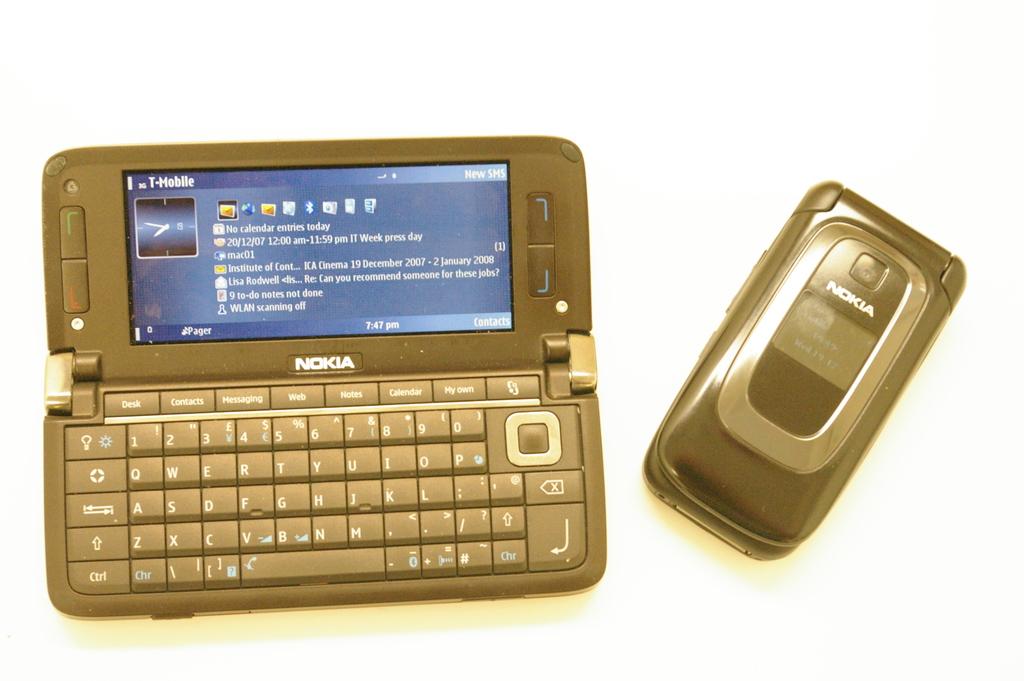Who makes this phone?
Make the answer very short. Nokia. Who is the carrier for this phone's service?
Offer a very short reply. T-mobile. 